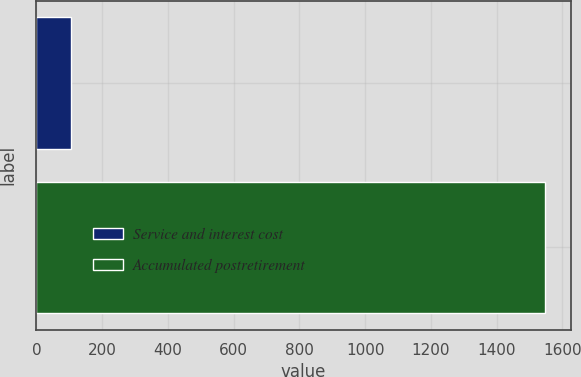<chart> <loc_0><loc_0><loc_500><loc_500><bar_chart><fcel>Service and interest cost<fcel>Accumulated postretirement<nl><fcel>106<fcel>1548<nl></chart> 